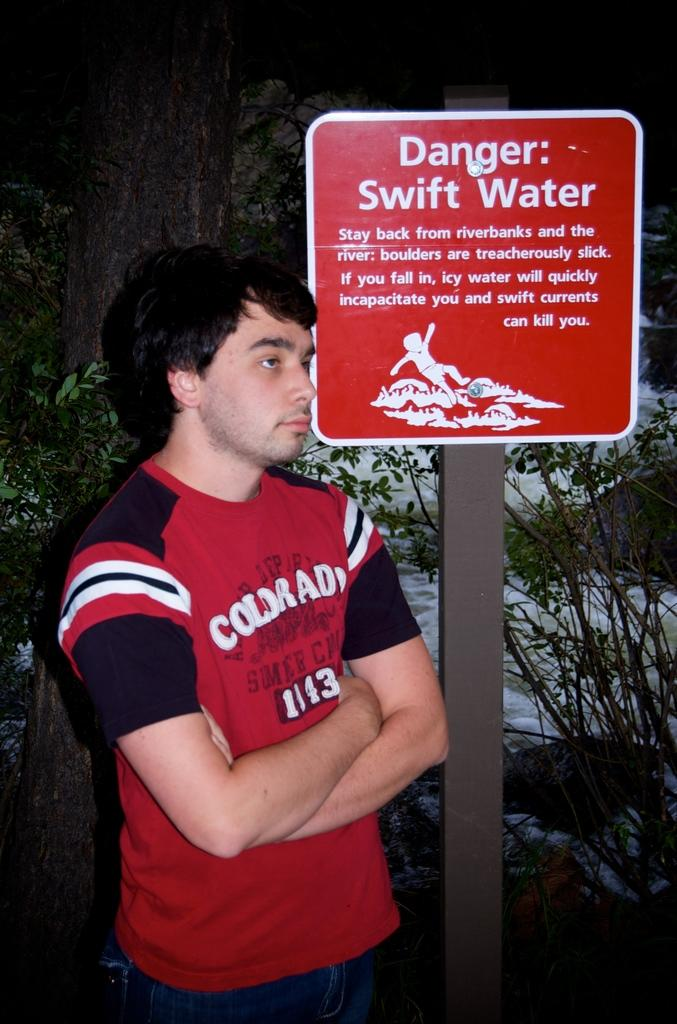<image>
Give a short and clear explanation of the subsequent image. Teenage rolls his eyes next to a danger swift water sign 